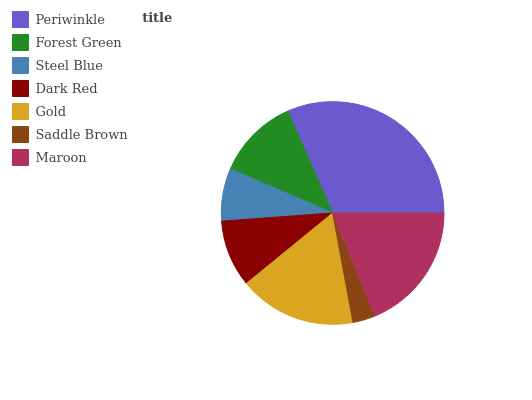Is Saddle Brown the minimum?
Answer yes or no. Yes. Is Periwinkle the maximum?
Answer yes or no. Yes. Is Forest Green the minimum?
Answer yes or no. No. Is Forest Green the maximum?
Answer yes or no. No. Is Periwinkle greater than Forest Green?
Answer yes or no. Yes. Is Forest Green less than Periwinkle?
Answer yes or no. Yes. Is Forest Green greater than Periwinkle?
Answer yes or no. No. Is Periwinkle less than Forest Green?
Answer yes or no. No. Is Forest Green the high median?
Answer yes or no. Yes. Is Forest Green the low median?
Answer yes or no. Yes. Is Periwinkle the high median?
Answer yes or no. No. Is Gold the low median?
Answer yes or no. No. 